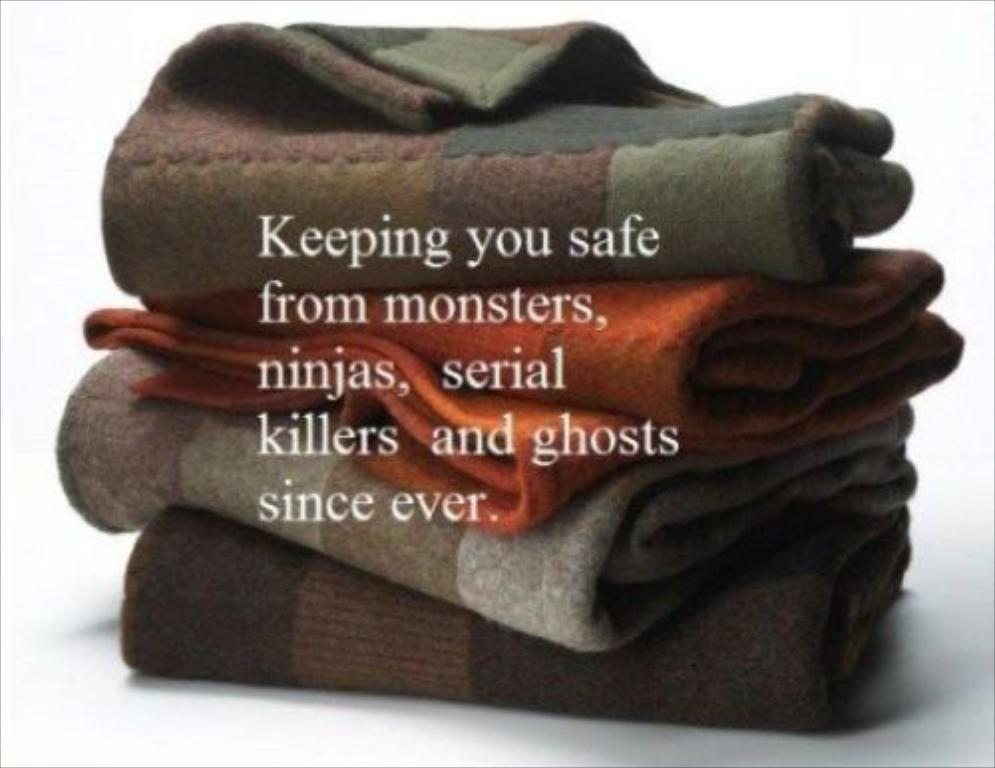What is placed on the white surface in the image? There are clothes on a white surface in the image. What else can be seen in the image besides the clothes? There is text on the image. What color is the background of the image? The background of the image is white. What type of fuel is being used by the van in the image? There is no van present in the image, so it is not possible to determine what type of fuel it might be using. 